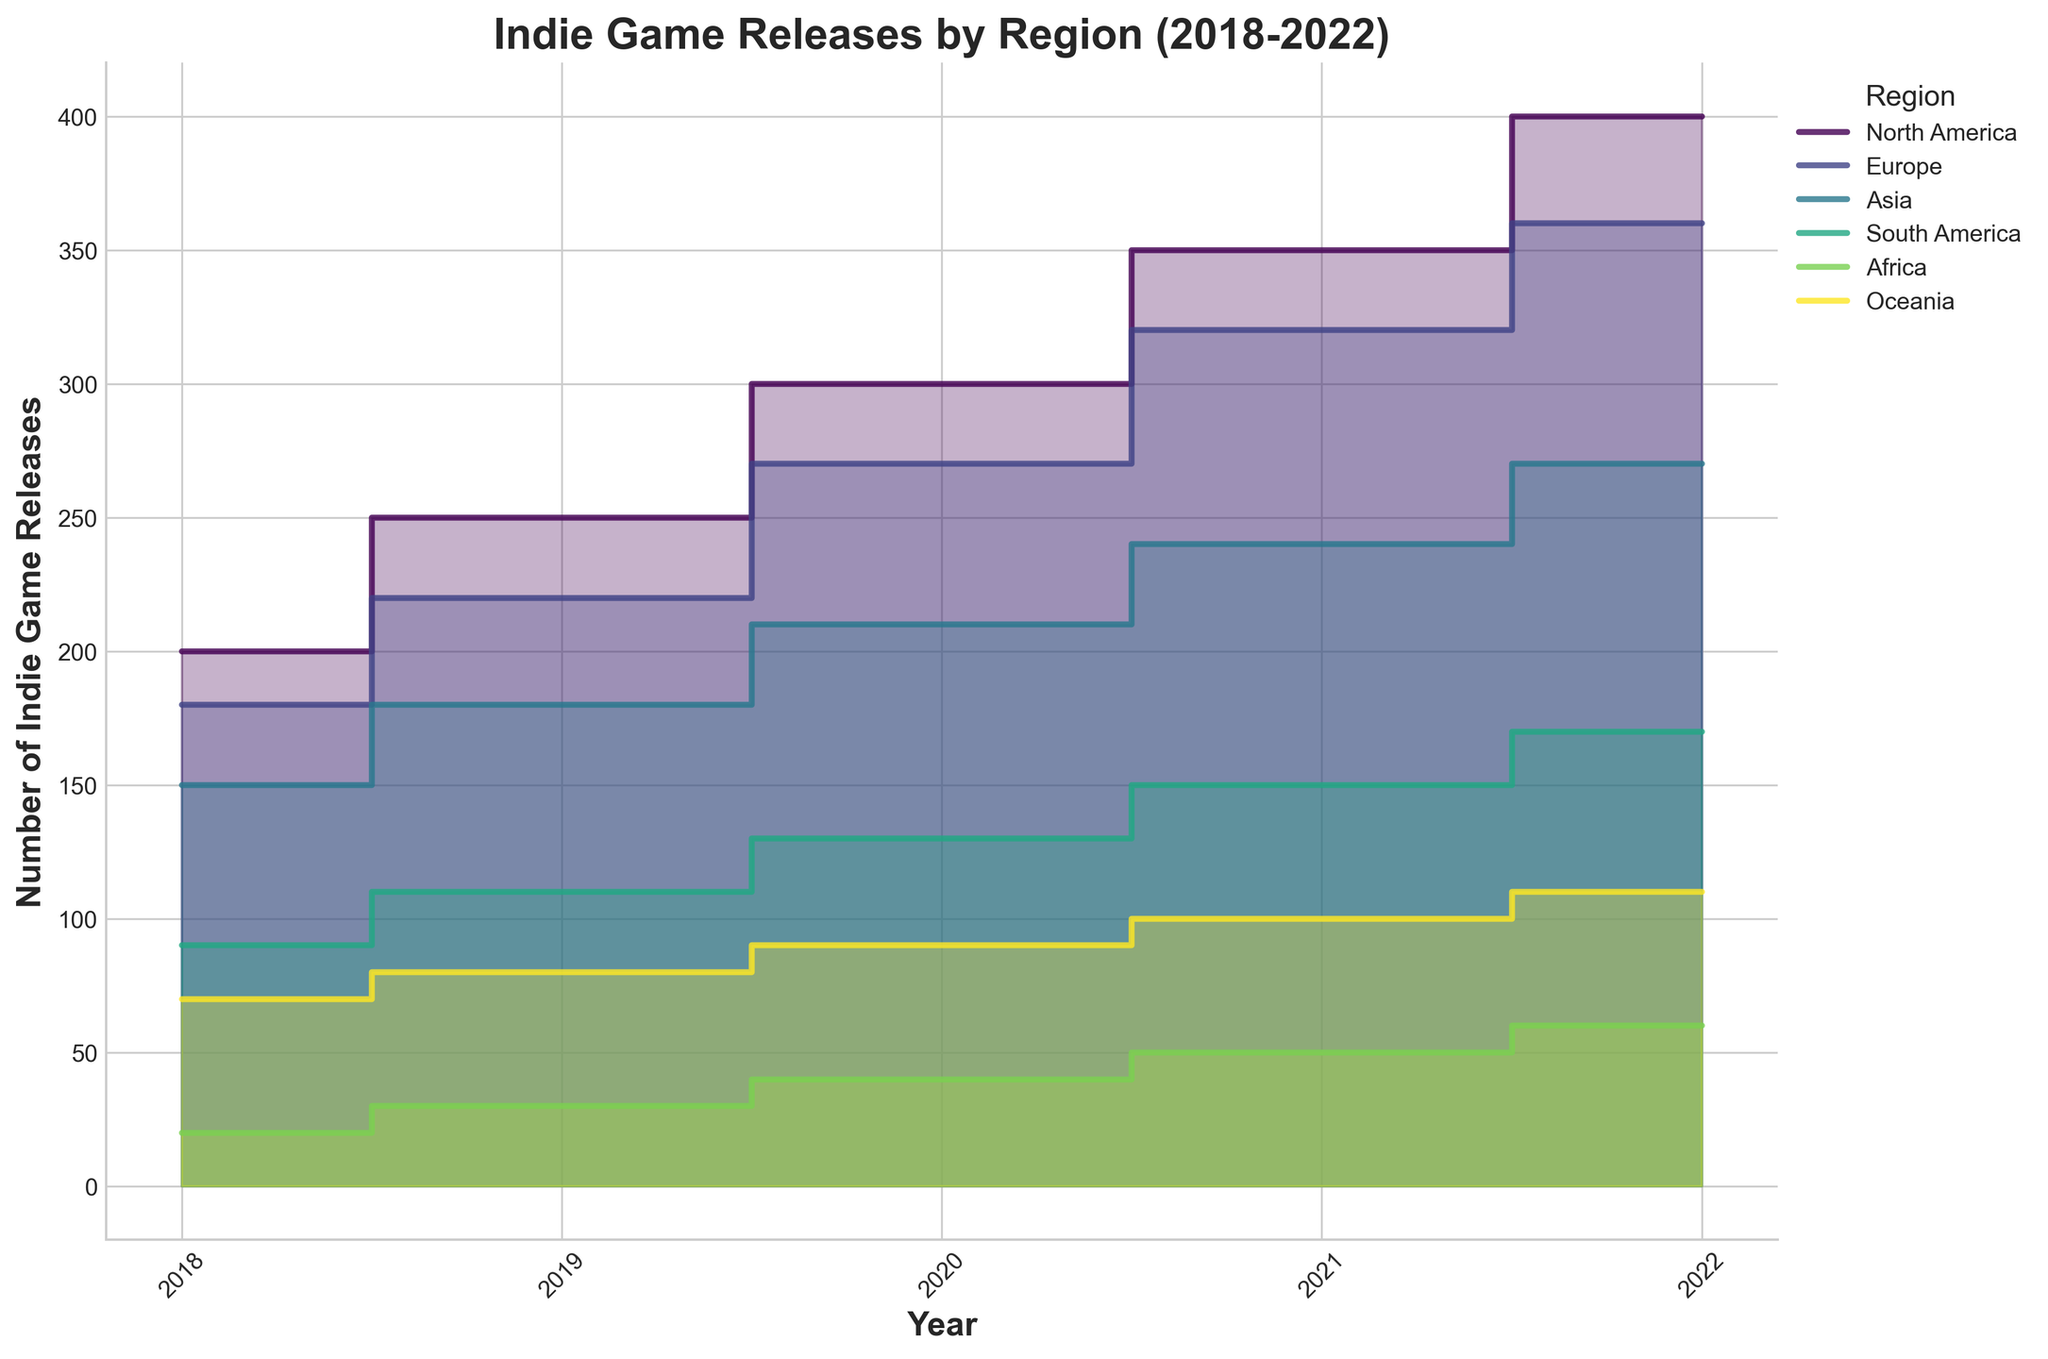What is the title of the figure? The title of the figure is displayed prominently at the top center of the chart. It summarizes the content of the chart.
Answer: Indie Game Releases by Region (2018-2022) What is the trend for Number of Indie Game Releases in North America from 2018 to 2022? By examining the step area chart for North America, observe the trend line which consistently increases from 200 in 2018 to 400 in 2022.
Answer: Increasing Which region had the least number of indie game releases in 2022? Look at the endings of the step area regions in 2022; the region with the lowest value represents the least number of releases. Africa ends at 60, which is the lowest.
Answer: Africa How does the number of game releases in Europe in 2021 compare to the number in Asia in 2020? In the chart, find the point for Europe in 2021 (320 releases) and compare it to the point for Asia in 2020 (210 releases). Since 320 is greater than 210, Europe has more releases.
Answer: Europe has more releases What is the total number of indie game releases in all regions in 2019? Sum the individual values for each region in 2019: North America (250) + Europe (220) + Asia (180) + South America (110) + Africa (30) + Oceania (80) = 870.
Answer: 870 What is the difference in the number of game releases between North America and South America in 2022? Look at the values for North America (400) and South America (170) in 2022 and calculate the difference: 400 - 170 = 230.
Answer: 230 On average, how many games were released in Africa from 2018 to 2022? Find the total number of releases in Africa over the years (20+30+40+50+60 = 200) and then divide by the number of years (5). That gives 200/5 = 40.
Answer: 40 In which year did Europe see the highest number of indie game releases? Trace the step area for Europe and find the highest value year - the end point of the European step area is highest in 2022 with 360 releases.
Answer: 2022 Between 2018 and 2022, which region had the greatest increase in the number of indie game releases? Calculate the difference from 2018 to 2022 for each region and compare: North America (200), Europe (180), Asia (120), South America (80), Africa (40), Oceania (40). North America had the largest increase.
Answer: North America How did Oceania's indie game releases change from 2018 to 2022? Review the step area for Oceania from 2018 (starting at 70) to 2022 (ending at 110), noting consistent annual increases.
Answer: Increased 